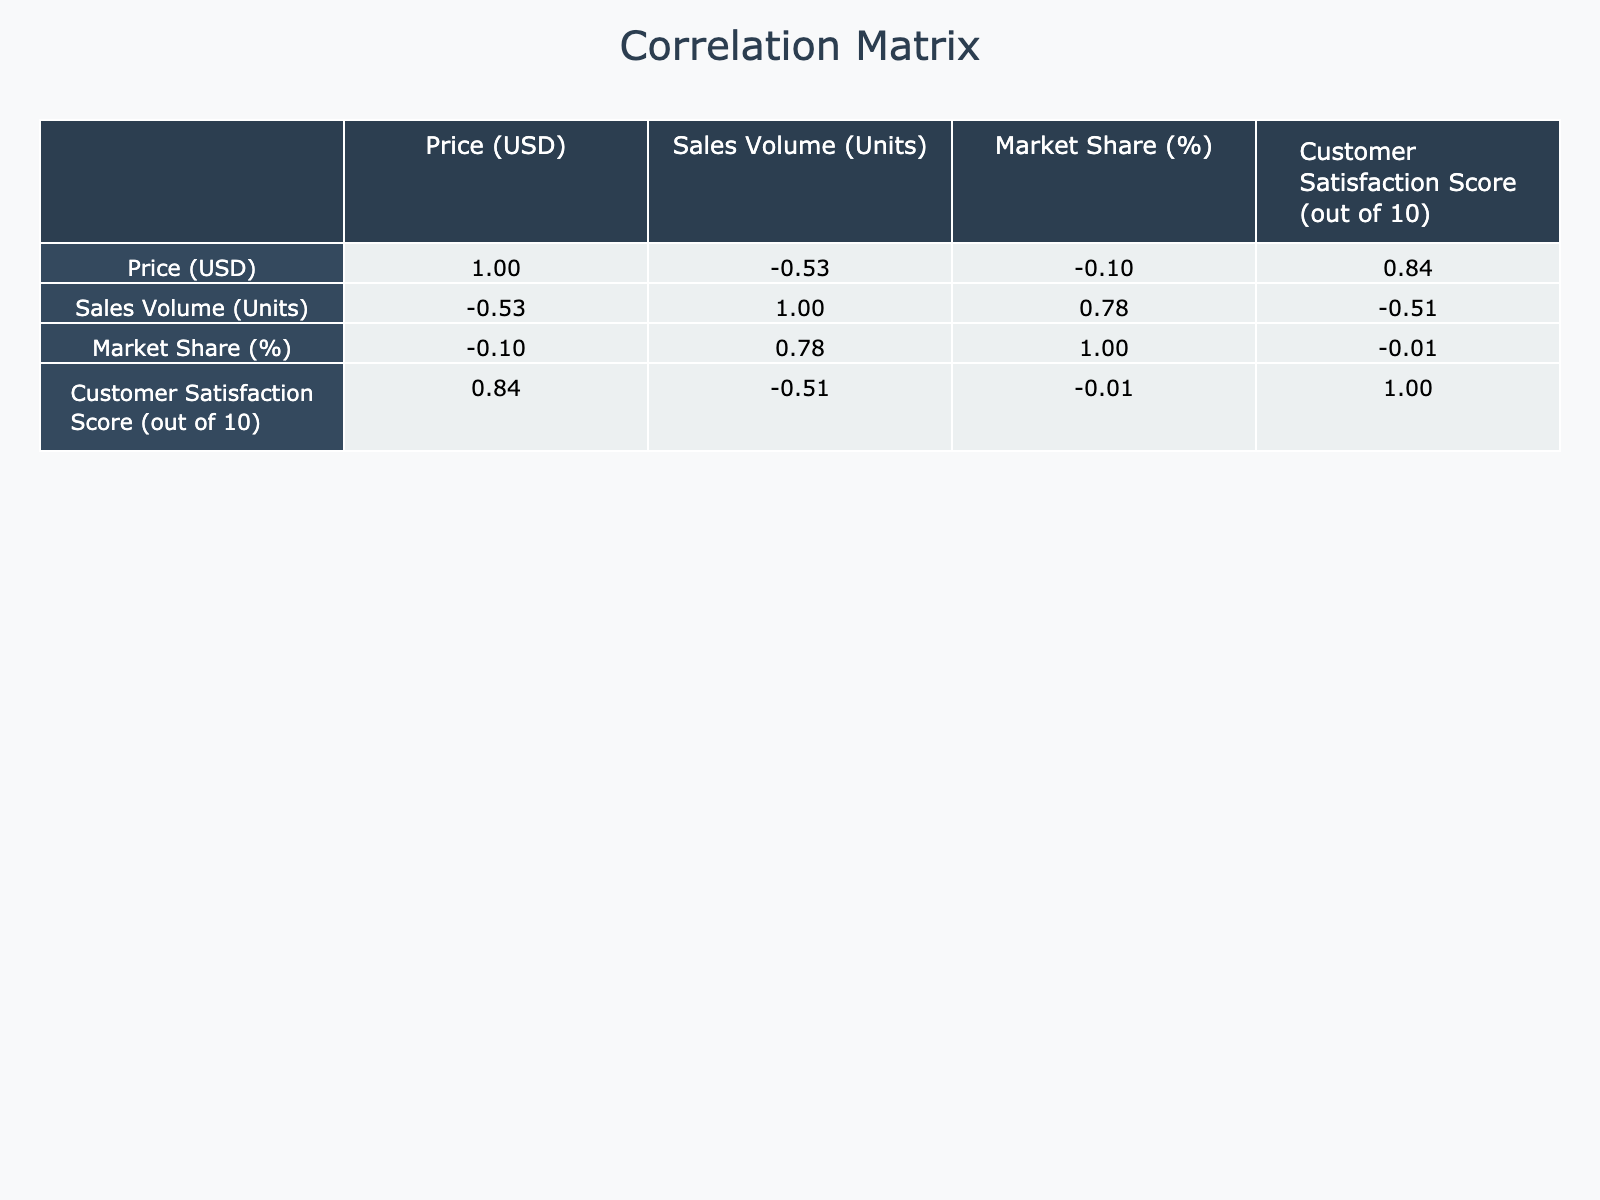What is the price of the Apple iPhone 13? The table provides the price directly for each product. Looking at the row for the Apple iPhone 13, the price listed is 999 USD.
Answer: 999 USD Which product has the highest market share? By scanning the 'Market Share (%)' column in the table, the highest percentage is 40%, which corresponds to the Amazon Echo Dot 4th Gen.
Answer: Amazon Echo Dot 4th Gen What is the average sales volume of all products listed? To find the average sales volume, sum the sales volumes: 15000 + 20000 + 12000 + 8000 + 50000 + 9000 + 4000 + 6000 + 4500 + 14000 = 111500. There are 10 products, so the average is 111500 / 10 = 11150.
Answer: 11150 Is customer satisfaction score higher for Sony WH-1000XM4 than for Microsoft Surface Pro 7? Looking at the 'Customer Satisfaction Score' column, the score for Sony WH-1000XM4 is 9.0 and for Microsoft Surface Pro 7 it is 8.7. Since 9.0 is greater than 8.7, the claim is true.
Answer: Yes What is the correlation between price and customer satisfaction score? The correlation matrix shows the relationship between price and customer satisfaction score. By locating the relevant cell in the table, the correlation coefficient between these two variables is found to be negative, suggesting as price increases, customer satisfaction tends to decrease.
Answer: Negative correlation 